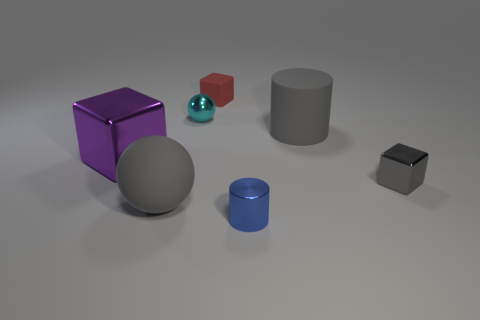What size is the cube behind the big rubber cylinder?
Give a very brief answer. Small. Does the large purple object have the same shape as the tiny red object?
Your answer should be very brief. Yes. How many large things are either blue balls or gray metallic cubes?
Make the answer very short. 0. There is a purple shiny thing; are there any large rubber cylinders in front of it?
Make the answer very short. No. Are there an equal number of tiny rubber blocks behind the small rubber thing and big matte things?
Keep it short and to the point. No. There is another metallic object that is the same shape as the big metal object; what size is it?
Provide a short and direct response. Small. Is the shape of the tiny blue thing the same as the large gray thing that is behind the purple metallic cube?
Offer a very short reply. Yes. What size is the sphere that is behind the big thing that is to the right of the cyan shiny object?
Provide a short and direct response. Small. Are there an equal number of cyan metallic objects behind the tiny cyan metallic ball and balls that are to the left of the small blue object?
Make the answer very short. No. There is a big object that is the same shape as the small rubber object; what color is it?
Provide a succinct answer. Purple. 